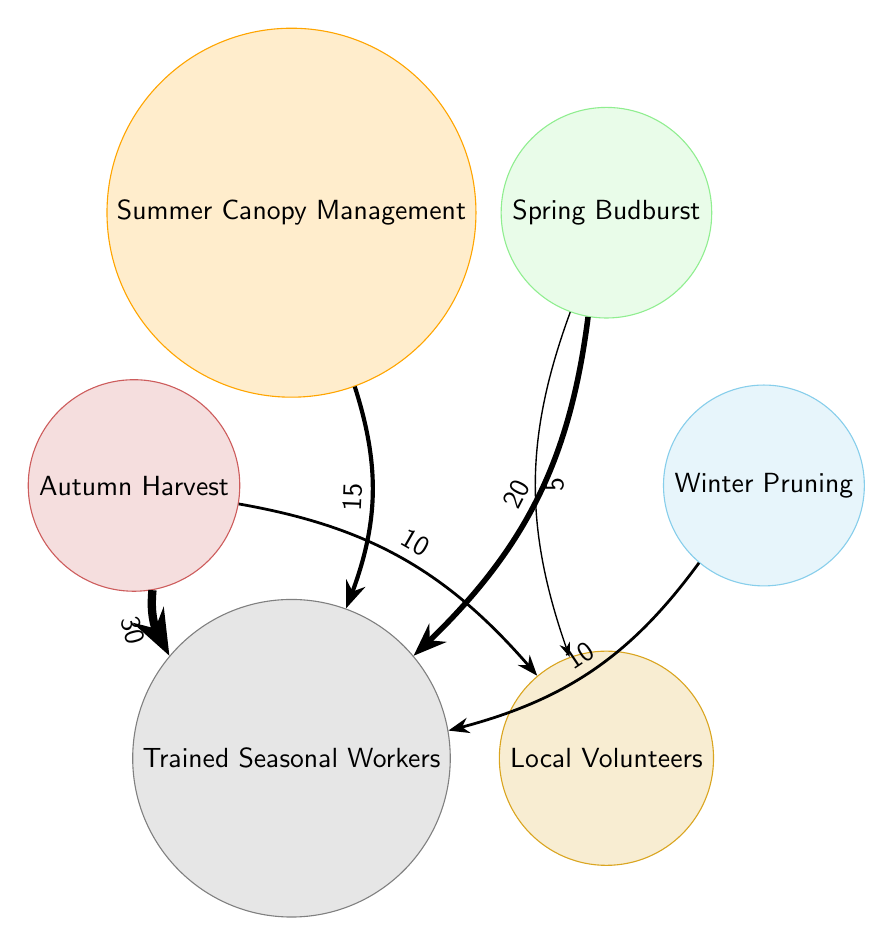What seasonal activity has the highest value of trained seasonal workers allocated? By examining the thickness of the arrows leading to "Trained Seasonal Workers", it's clear that "Autumn Harvest" has the thickest arrow with a value of 30, indicating the highest allocation.
Answer: Autumn Harvest How many total nodes are present in the diagram? The diagram contains six nodes: Winter Pruning, Spring Budburst, Summer Canopy Management, Autumn Harvest, Trained Seasonal Workers, and Local Volunteers. Counting them gives a total of six nodes.
Answer: 6 What is the allocation value of local volunteers for spring budburst activity? The spring budburst activity has an outgoing arrow to "Local Volunteers" with a value of 5, signifying the allocation for this activity.
Answer: 5 Which activity has the least allocation of trained seasonal workers? Among the links to "Trained Seasonal Workers", "Winter Pruning" has the lowest allocation with a value of 10.
Answer: Winter Pruning Which seasonal activity uses both trained seasonal workers and local volunteers? The "Autumn Harvest" and "Spring Budburst" activities both connect to "Trained Seasonal Workers" and "Local Volunteers", indicating that both types of workforce are allocated to these activities.
Answer: Autumn Harvest, Spring Budburst What is the total value of trained seasonal workers across all activities? Adding the values of all links leading to "Trained Seasonal Workers" (10 + 20 + 15 + 30) results in a total of 75 workers allocated for the various activities.
Answer: 75 How many links are there to the local volunteers? There are two outgoing links to "Local Volunteers" from Spring Budburst and Autumn Harvest, indicating their respective allocations. Counting these gives us two links.
Answer: 2 What are the colors associated with the summer canopy management activity? The "Summer Canopy Management" node is represented with an orange color fill and an outline, as denoted in the diagram's color coding scheme.
Answer: Orange Which activity requires the least worker allocation from both worker types? Looking at the values, "Winter Pruning" has the least allocation from both worker types. It requires only trained seasonal workers with a value of 10 and does not allocate to local volunteers.
Answer: Winter Pruning 